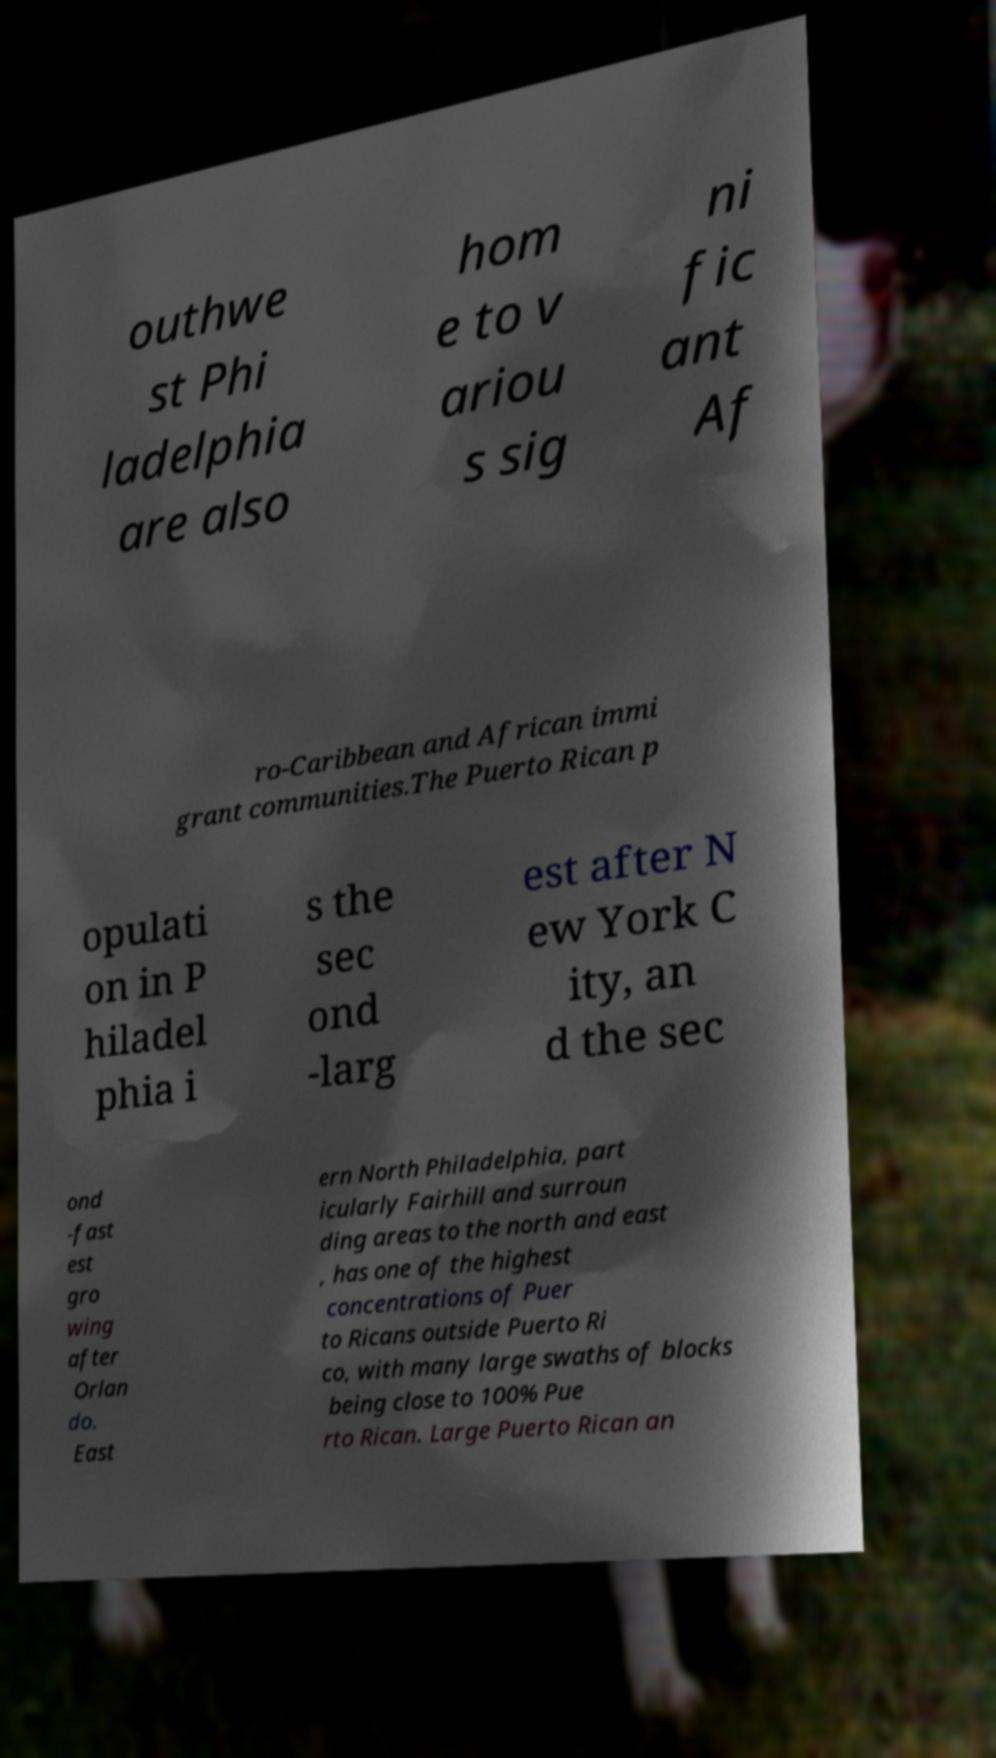What messages or text are displayed in this image? I need them in a readable, typed format. outhwe st Phi ladelphia are also hom e to v ariou s sig ni fic ant Af ro-Caribbean and African immi grant communities.The Puerto Rican p opulati on in P hiladel phia i s the sec ond -larg est after N ew York C ity, an d the sec ond -fast est gro wing after Orlan do. East ern North Philadelphia, part icularly Fairhill and surroun ding areas to the north and east , has one of the highest concentrations of Puer to Ricans outside Puerto Ri co, with many large swaths of blocks being close to 100% Pue rto Rican. Large Puerto Rican an 